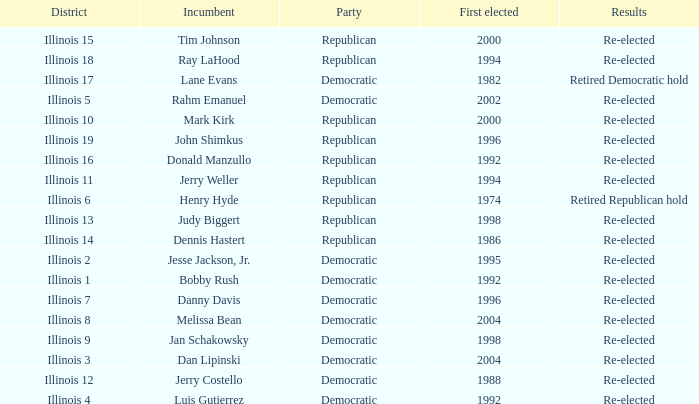What is the Party of District of Illinois 19 with an Incumbent First elected in 1996? Republican. 